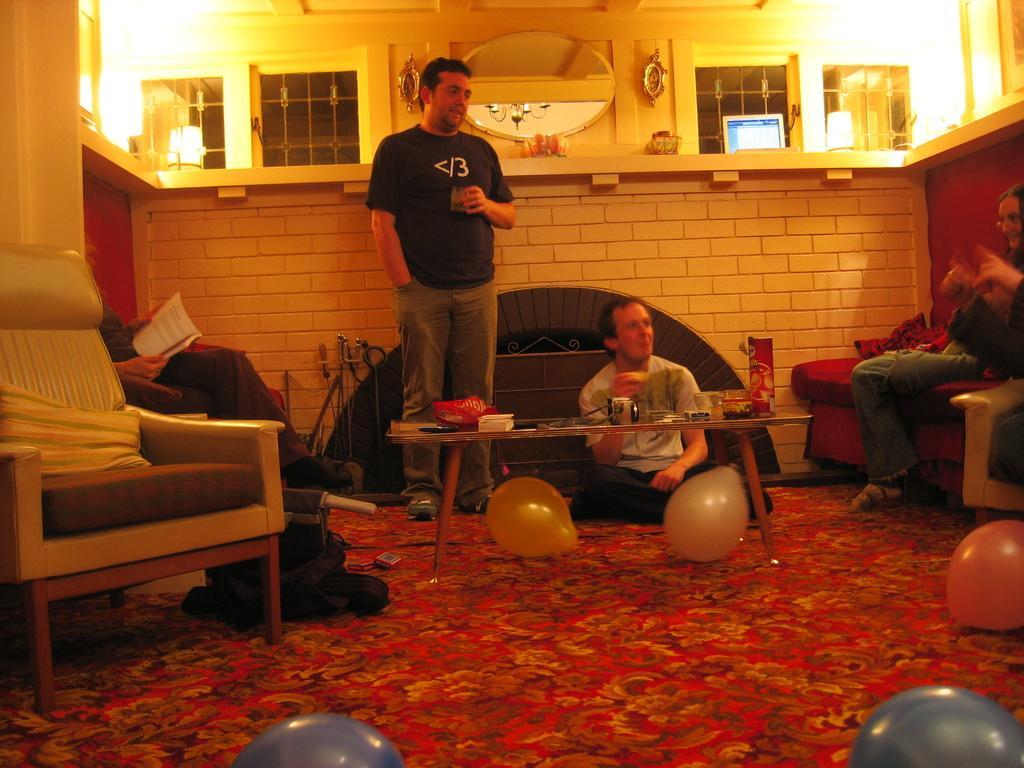In one or two sentences, can you explain what this image depicts? In this image there are four people In the middle there is a man he is standing wear t shirt, trouser and shoes. On the right there is a woman she is smiling. On the left there is a man, chair, pillar and window. At the bottom there are balloons and mat. 